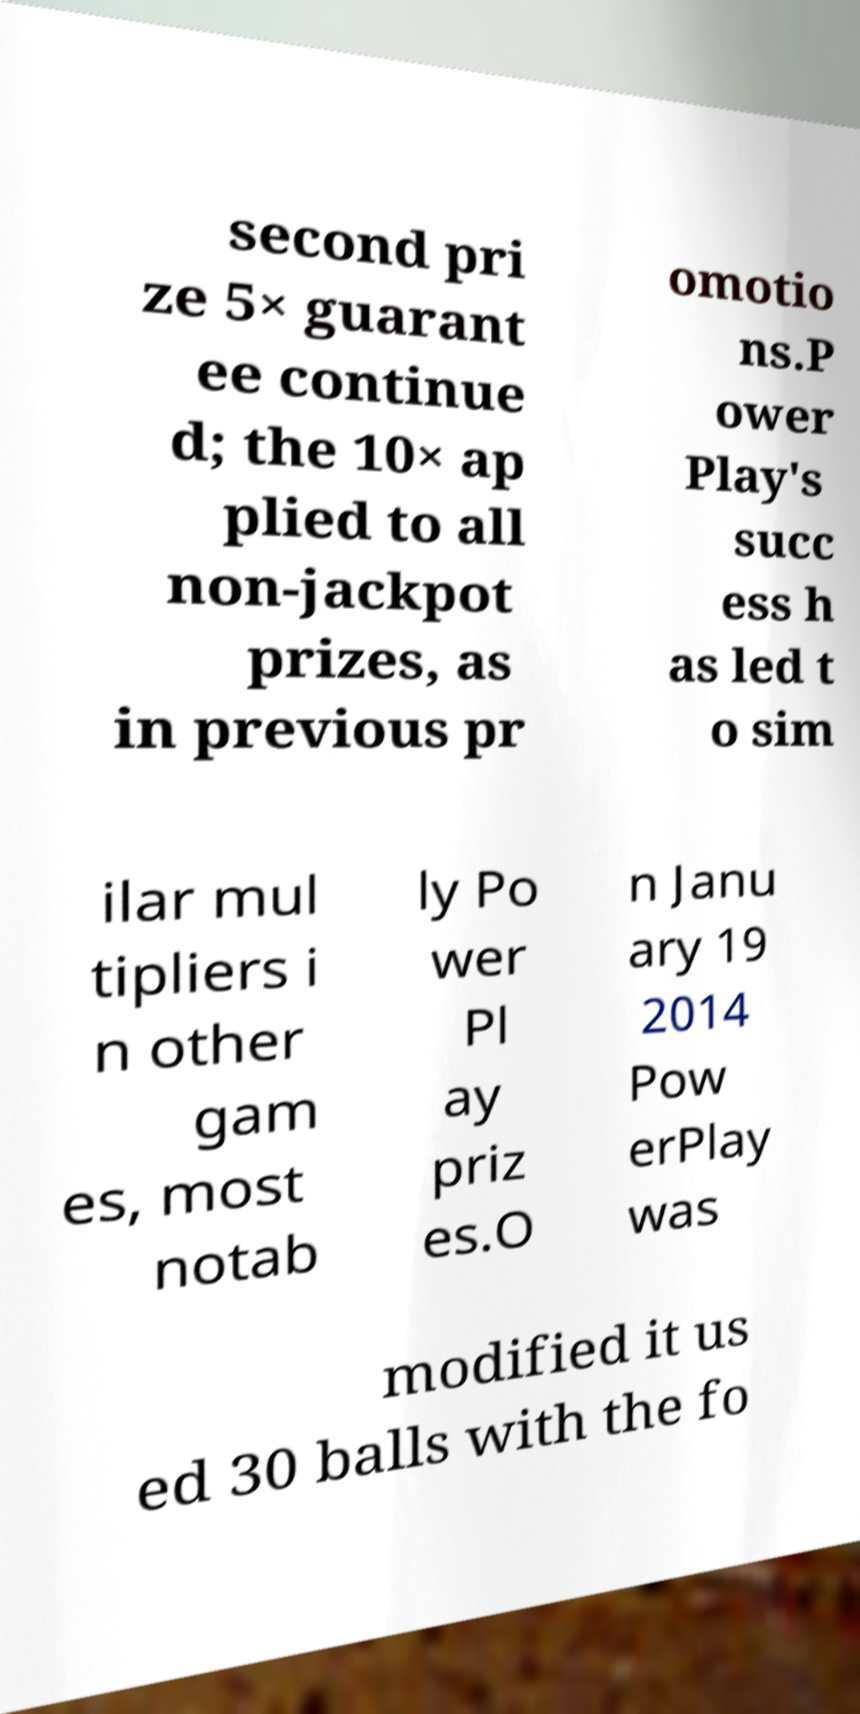For documentation purposes, I need the text within this image transcribed. Could you provide that? second pri ze 5× guarant ee continue d; the 10× ap plied to all non-jackpot prizes, as in previous pr omotio ns.P ower Play's succ ess h as led t o sim ilar mul tipliers i n other gam es, most notab ly Po wer Pl ay priz es.O n Janu ary 19 2014 Pow erPlay was modified it us ed 30 balls with the fo 